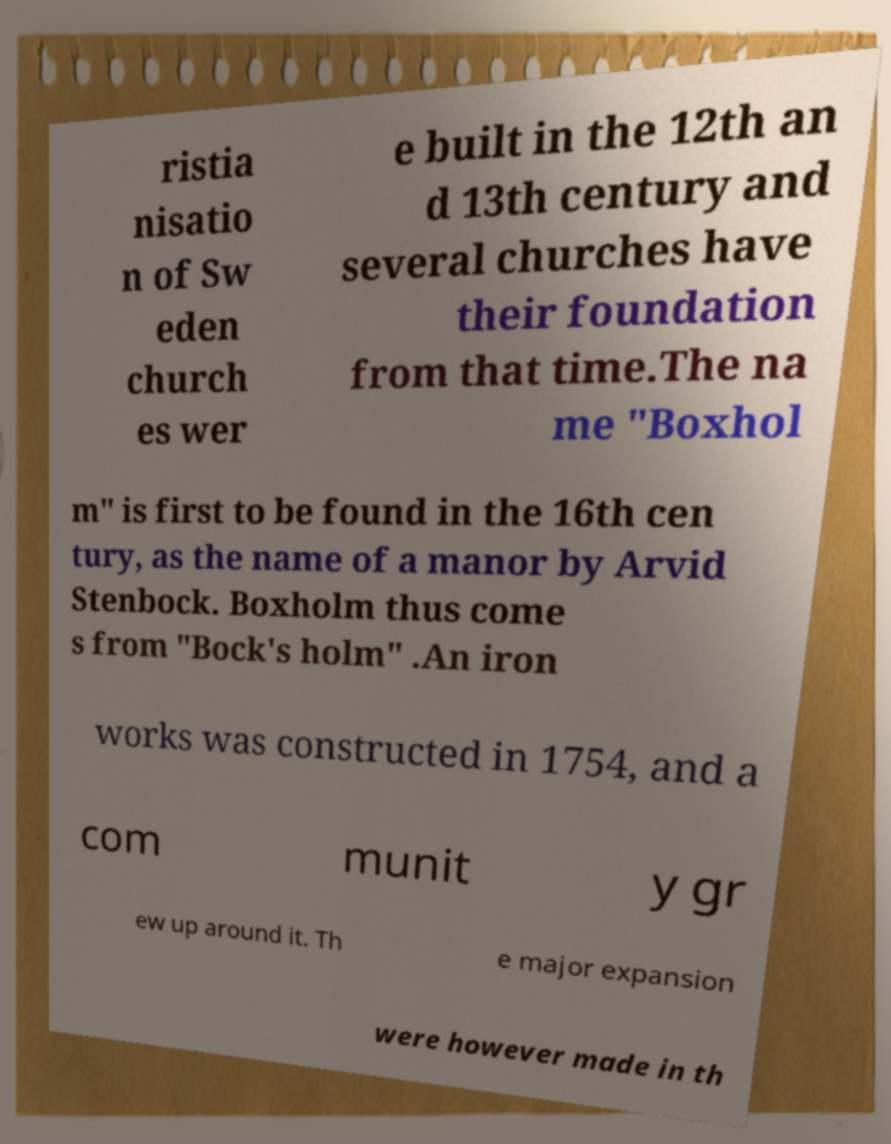I need the written content from this picture converted into text. Can you do that? ristia nisatio n of Sw eden church es wer e built in the 12th an d 13th century and several churches have their foundation from that time.The na me "Boxhol m" is first to be found in the 16th cen tury, as the name of a manor by Arvid Stenbock. Boxholm thus come s from "Bock's holm" .An iron works was constructed in 1754, and a com munit y gr ew up around it. Th e major expansion were however made in th 